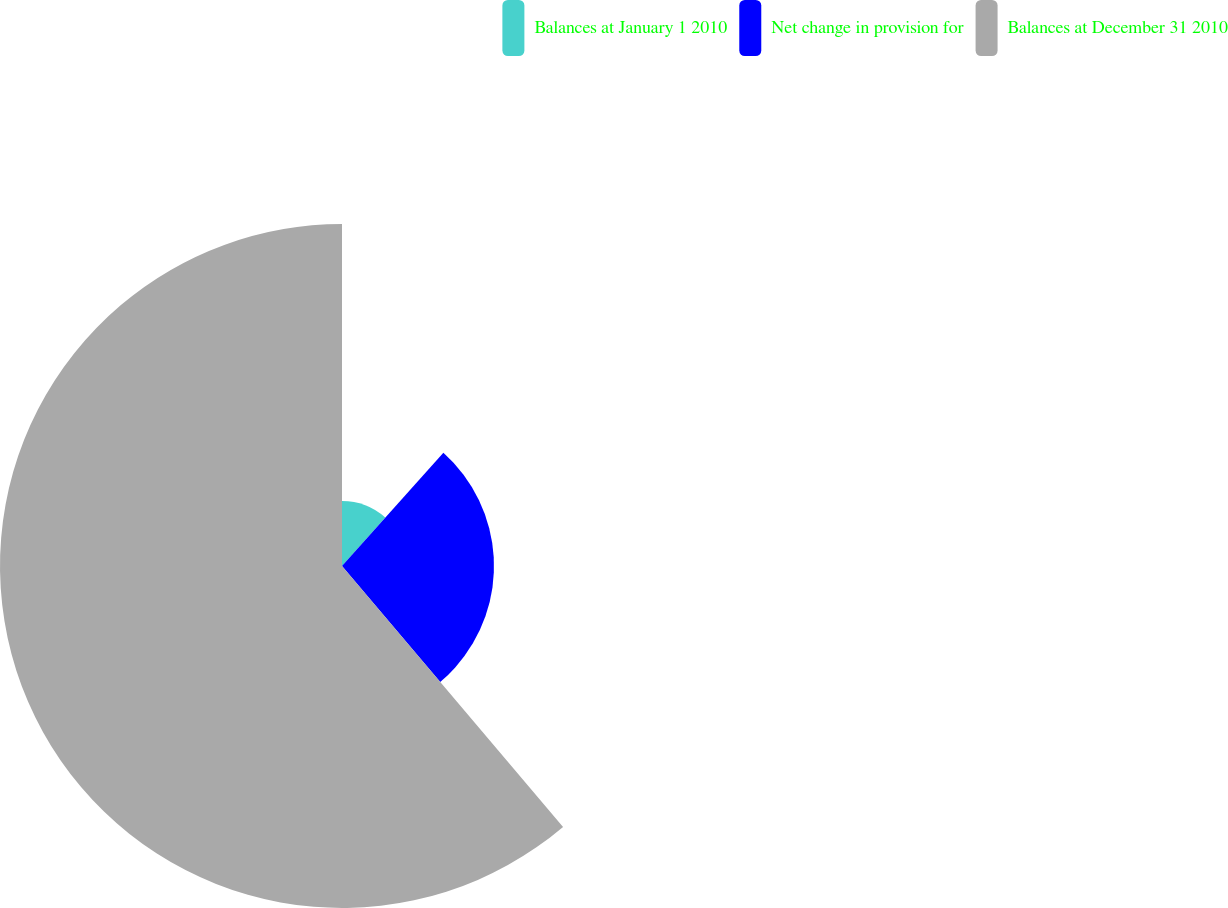Convert chart. <chart><loc_0><loc_0><loc_500><loc_500><pie_chart><fcel>Balances at January 1 2010<fcel>Net change in provision for<fcel>Balances at December 31 2010<nl><fcel>11.62%<fcel>27.19%<fcel>61.18%<nl></chart> 